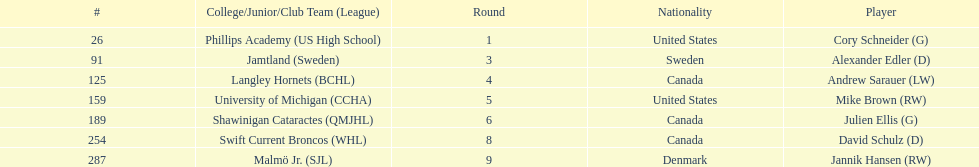Which players have canadian nationality? Andrew Sarauer (LW), Julien Ellis (G), David Schulz (D). Of those, which attended langley hornets? Andrew Sarauer (LW). 